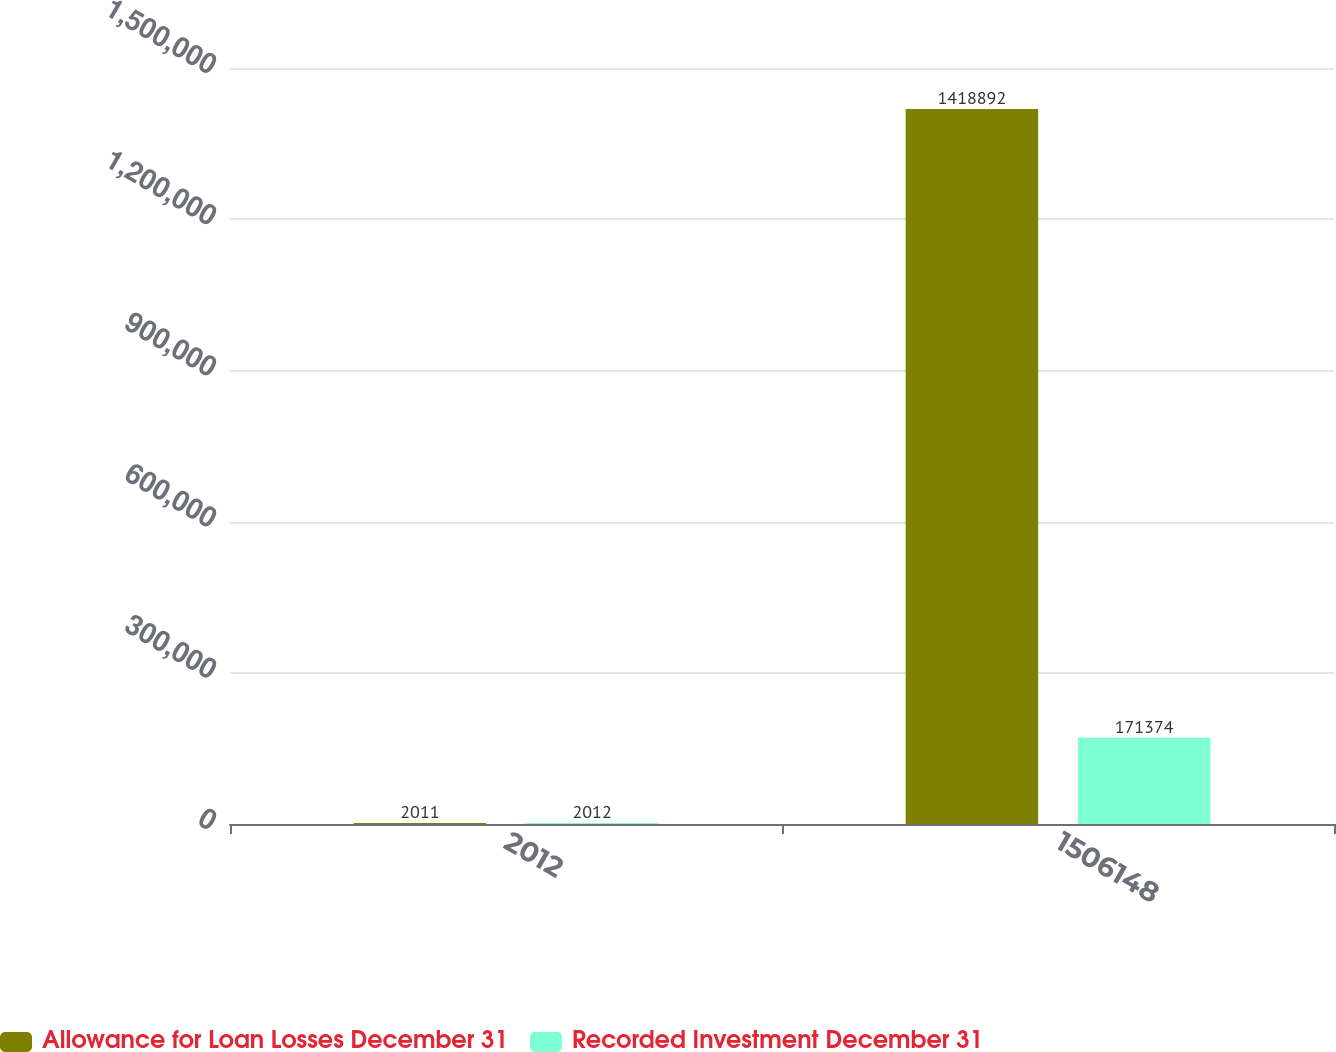Convert chart to OTSL. <chart><loc_0><loc_0><loc_500><loc_500><stacked_bar_chart><ecel><fcel>2012<fcel>1506148<nl><fcel>Allowance for Loan Losses December 31<fcel>2011<fcel>1.41889e+06<nl><fcel>Recorded Investment December 31<fcel>2012<fcel>171374<nl></chart> 